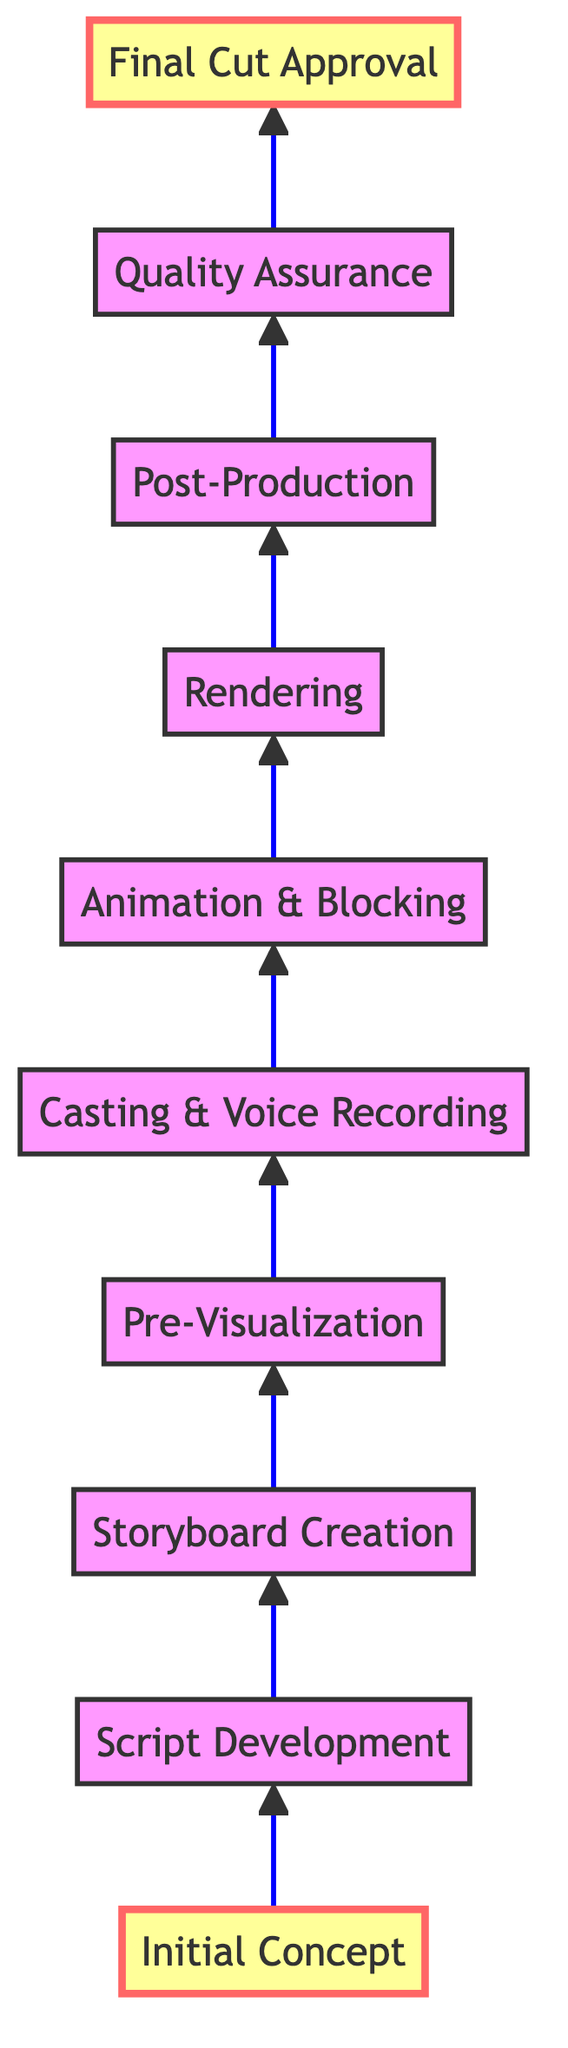What is the first step in the evolution of a game cinematic? The diagram shows that the first step in the process is "Initial Concept." It is the starting point of the entire flow.
Answer: Initial Concept How many steps are there in the evolution of a game cinematic? By counting the nodes in the diagram, there are ten steps involved in the evolution from the initial concept to final cut.
Answer: Ten What comes after "Pre-Visualization"? Referring to the flow chart, after "Pre-Visualization," the next step is "Casting & Voice Recording." This follows the progression outlined in the diagram.
Answer: Casting & Voice Recording What is the final step in the process? According to the diagram, the last step is "Final Cut Approval," which indicates the end of the cinematic production process.
Answer: Final Cut Approval How many nodes are highlighted in the diagram? The diagram highlights two nodes, which are "Initial Concept" and "Final Cut Approval," indicating important stages in the process.
Answer: Two What is the relationship between "Rendering" and "Post-Production"? In the flowchart, "Rendering" leads directly to "Post-Production," showing that rendering is a prerequisite for the post-production phase.
Answer: Rendering leads to Post-Production What is required before moving on to "Quality Assurance"? The diagram specifies that the step before "Quality Assurance" is "Post-Production," meaning all editing and effects must be applied first.
Answer: Post-Production Which step involves voice actors? The step involving voice actors is "Casting & Voice Recording," as indicated by the description linked to that node in the flowchart.
Answer: Casting & Voice Recording What happens between "Animation & Blocking" and "Rendering"? According to the diagram, "Animation & Blocking" is followed by "Rendering"; thus, rendering occurs after animation is completed.
Answer: Rendering follows Animation & Blocking 